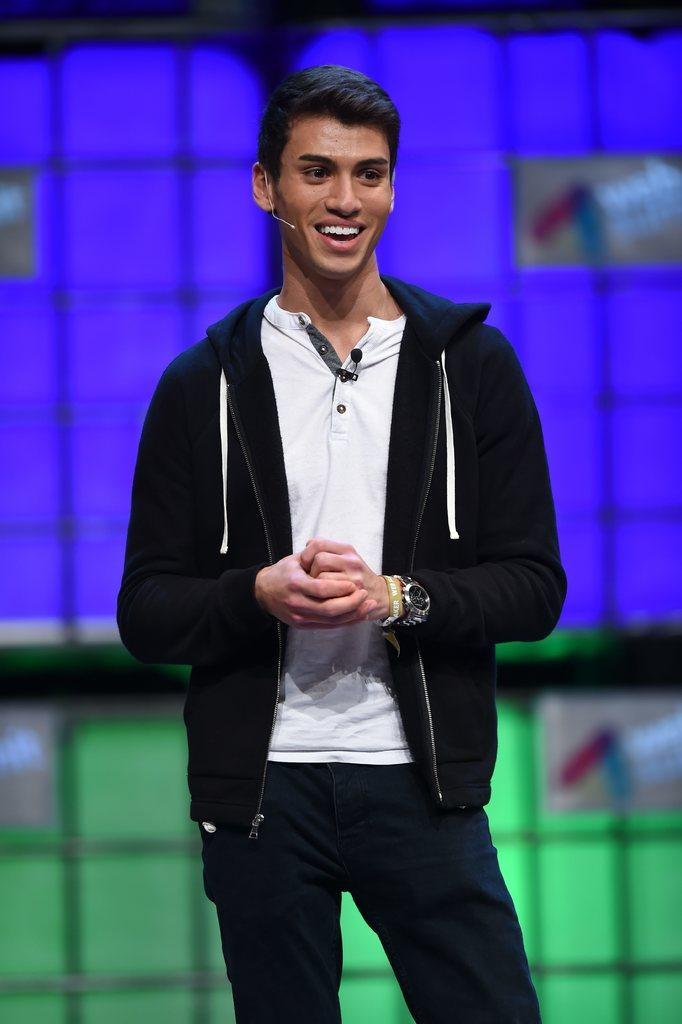What is the main subject of the image? There is a person standing in the image. Can you describe the person's attire? The person is wearing a white, black, and navy blue color dress. What can be seen in the background of the image? There is a green and blue color surface in the background of the image. What type of orange is the person holding in the image? There is no orange present in the image; the person is wearing a dress with the mentioned colors. Can you see an airplane in the image? There is no airplane present in the image; the main subject is a person standing. 